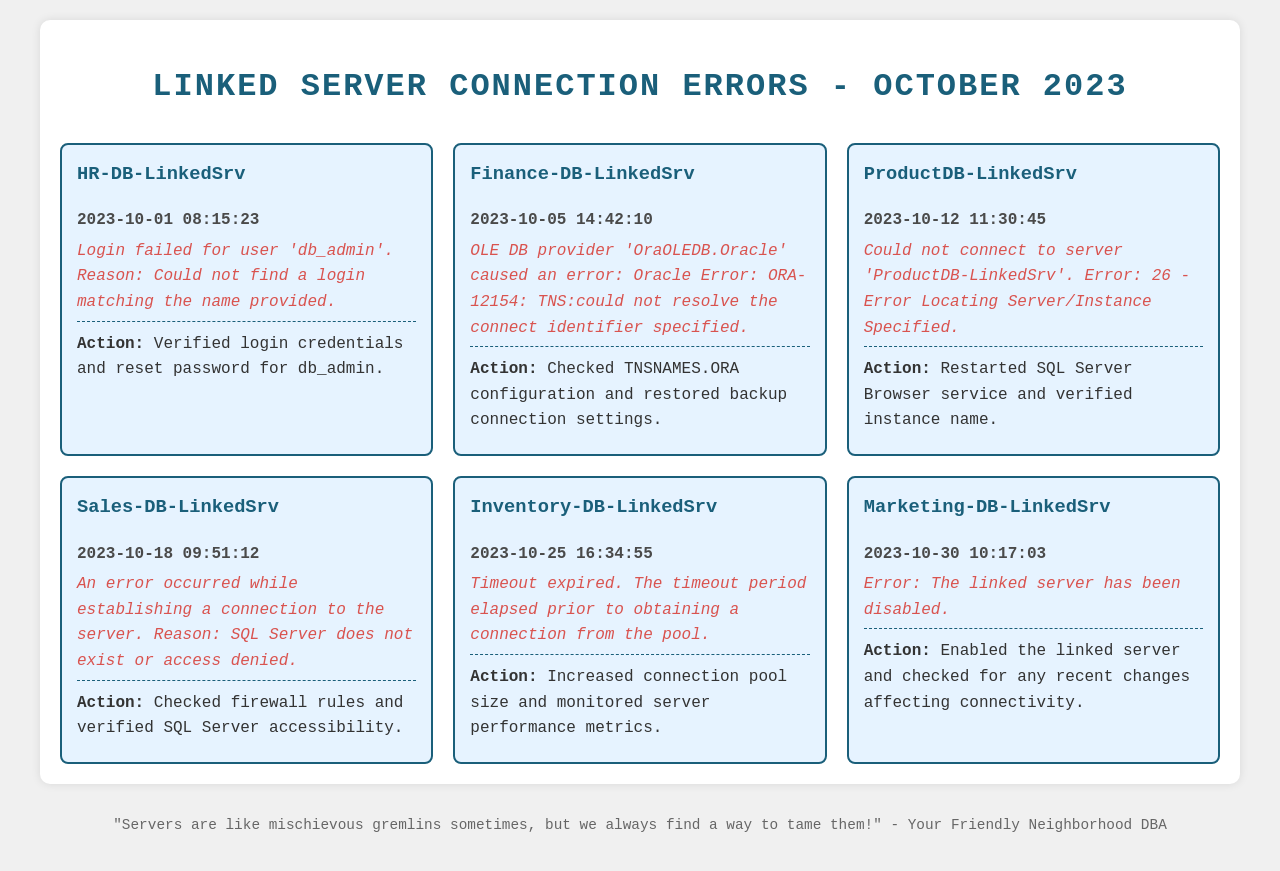What was the first error logged in October 2023? The first error logged was for 'HR-DB-LinkedSrv' on October 1, 2023, at 08:15:23.
Answer: Login failed for user 'db_admin' What is the error code associated with the Finance-DB-LinkedSrv? The error message for Finance-DB-LinkedSrv mentions an Oracle Error: ORA-12154.
Answer: ORA-12154 When did the connection error for ProductDB-LinkedSrv occur? The logged error for ProductDB-LinkedSrv occurred on October 12, 2023.
Answer: October 12, 2023 How many errors were logged for Linked servers in October 2023? There are a total of six error log entries detailed in the document.
Answer: Six What action was taken for the connection error on October 30? The action taken was to enable the linked server.
Answer: Enabled the linked server Which linked server reported a timeout error? The error related to the timeout was logged for 'Inventory-DB-LinkedSrv'.
Answer: Inventory-DB-LinkedSrv What was the reason given for the Sales-DB-LinkedSrv error? The reason provided was that SQL Server does not exist or access was denied.
Answer: SQL Server does not exist or access denied What action was taken on October 25 for the Inventory-DB-LinkedSrv? The action taken was to increase the connection pool size.
Answer: Increased connection pool size 